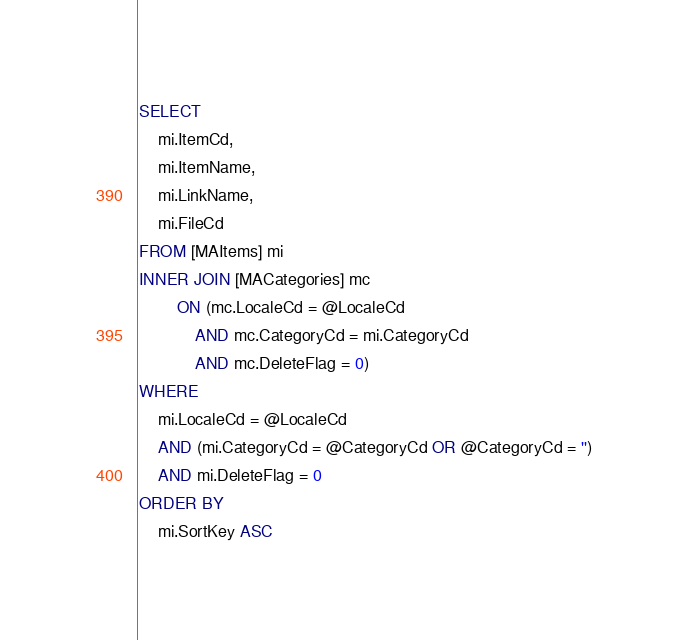<code> <loc_0><loc_0><loc_500><loc_500><_SQL_>SELECT
	mi.ItemCd,
	mi.ItemName,
	mi.LinkName,
	mi.FileCd
FROM [MAItems] mi
INNER JOIN [MACategories] mc
		ON (mc.LocaleCd = @LocaleCd
			AND mc.CategoryCd = mi.CategoryCd
			AND mc.DeleteFlag = 0)
WHERE
	mi.LocaleCd = @LocaleCd
	AND (mi.CategoryCd = @CategoryCd OR @CategoryCd = '')
	AND mi.DeleteFlag = 0
ORDER BY
	mi.SortKey ASC</code> 